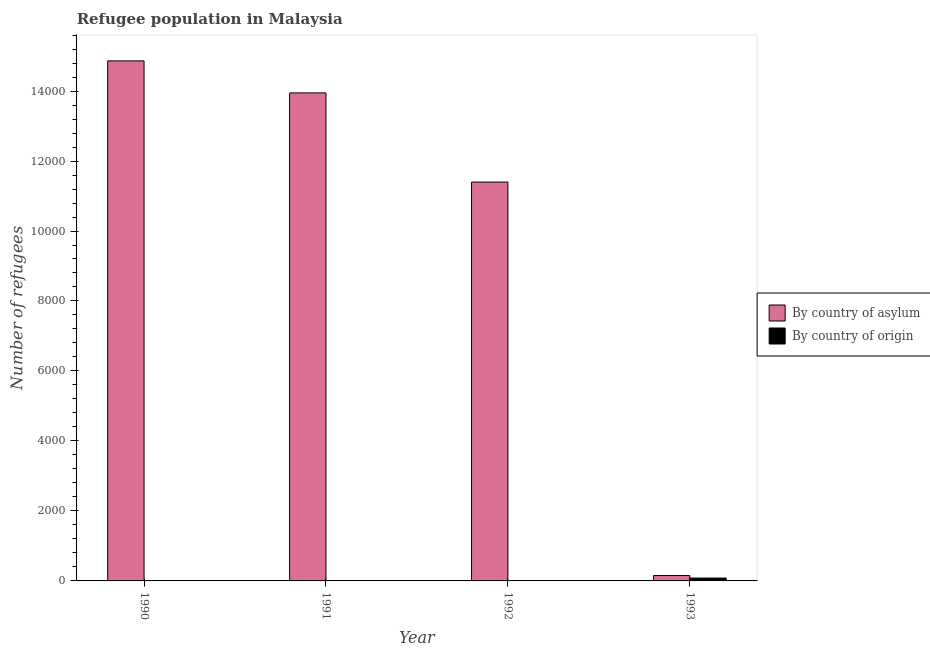How many groups of bars are there?
Offer a terse response. 4. Are the number of bars per tick equal to the number of legend labels?
Make the answer very short. Yes. How many bars are there on the 4th tick from the right?
Your answer should be compact. 2. What is the label of the 1st group of bars from the left?
Give a very brief answer. 1990. What is the number of refugees by country of origin in 1990?
Your answer should be very brief. 3. Across all years, what is the maximum number of refugees by country of asylum?
Provide a short and direct response. 1.49e+04. Across all years, what is the minimum number of refugees by country of origin?
Offer a terse response. 3. In which year was the number of refugees by country of asylum minimum?
Offer a very short reply. 1993. What is the total number of refugees by country of asylum in the graph?
Your answer should be compact. 4.04e+04. What is the difference between the number of refugees by country of asylum in 1990 and that in 1991?
Keep it short and to the point. 915. What is the difference between the number of refugees by country of asylum in 1991 and the number of refugees by country of origin in 1993?
Your answer should be compact. 1.38e+04. What is the average number of refugees by country of asylum per year?
Your answer should be very brief. 1.01e+04. What is the ratio of the number of refugees by country of asylum in 1991 to that in 1992?
Offer a very short reply. 1.22. Is the number of refugees by country of origin in 1991 less than that in 1992?
Offer a very short reply. No. What is the difference between the highest and the second highest number of refugees by country of asylum?
Your answer should be compact. 915. What is the difference between the highest and the lowest number of refugees by country of origin?
Offer a terse response. 79. In how many years, is the number of refugees by country of origin greater than the average number of refugees by country of origin taken over all years?
Your answer should be compact. 1. Is the sum of the number of refugees by country of asylum in 1991 and 1993 greater than the maximum number of refugees by country of origin across all years?
Give a very brief answer. No. What does the 1st bar from the left in 1990 represents?
Offer a terse response. By country of asylum. What does the 1st bar from the right in 1990 represents?
Offer a very short reply. By country of origin. Are all the bars in the graph horizontal?
Offer a very short reply. No. Does the graph contain grids?
Your answer should be compact. No. How many legend labels are there?
Offer a very short reply. 2. What is the title of the graph?
Keep it short and to the point. Refugee population in Malaysia. What is the label or title of the Y-axis?
Provide a succinct answer. Number of refugees. What is the Number of refugees in By country of asylum in 1990?
Provide a succinct answer. 1.49e+04. What is the Number of refugees of By country of origin in 1990?
Make the answer very short. 3. What is the Number of refugees in By country of asylum in 1991?
Offer a terse response. 1.39e+04. What is the Number of refugees in By country of origin in 1991?
Make the answer very short. 4. What is the Number of refugees in By country of asylum in 1992?
Make the answer very short. 1.14e+04. What is the Number of refugees in By country of asylum in 1993?
Your answer should be very brief. 154. What is the Number of refugees of By country of origin in 1993?
Provide a succinct answer. 82. Across all years, what is the maximum Number of refugees in By country of asylum?
Provide a succinct answer. 1.49e+04. Across all years, what is the minimum Number of refugees of By country of asylum?
Provide a short and direct response. 154. What is the total Number of refugees in By country of asylum in the graph?
Your answer should be very brief. 4.04e+04. What is the total Number of refugees in By country of origin in the graph?
Make the answer very short. 93. What is the difference between the Number of refugees in By country of asylum in 1990 and that in 1991?
Offer a terse response. 915. What is the difference between the Number of refugees of By country of origin in 1990 and that in 1991?
Keep it short and to the point. -1. What is the difference between the Number of refugees in By country of asylum in 1990 and that in 1992?
Offer a terse response. 3463. What is the difference between the Number of refugees of By country of asylum in 1990 and that in 1993?
Your response must be concise. 1.47e+04. What is the difference between the Number of refugees in By country of origin in 1990 and that in 1993?
Provide a short and direct response. -79. What is the difference between the Number of refugees in By country of asylum in 1991 and that in 1992?
Your response must be concise. 2548. What is the difference between the Number of refugees of By country of origin in 1991 and that in 1992?
Your answer should be compact. 0. What is the difference between the Number of refugees of By country of asylum in 1991 and that in 1993?
Make the answer very short. 1.38e+04. What is the difference between the Number of refugees in By country of origin in 1991 and that in 1993?
Your answer should be very brief. -78. What is the difference between the Number of refugees of By country of asylum in 1992 and that in 1993?
Your answer should be compact. 1.12e+04. What is the difference between the Number of refugees of By country of origin in 1992 and that in 1993?
Offer a very short reply. -78. What is the difference between the Number of refugees of By country of asylum in 1990 and the Number of refugees of By country of origin in 1991?
Give a very brief answer. 1.49e+04. What is the difference between the Number of refugees in By country of asylum in 1990 and the Number of refugees in By country of origin in 1992?
Your response must be concise. 1.49e+04. What is the difference between the Number of refugees in By country of asylum in 1990 and the Number of refugees in By country of origin in 1993?
Your response must be concise. 1.48e+04. What is the difference between the Number of refugees of By country of asylum in 1991 and the Number of refugees of By country of origin in 1992?
Offer a terse response. 1.39e+04. What is the difference between the Number of refugees in By country of asylum in 1991 and the Number of refugees in By country of origin in 1993?
Keep it short and to the point. 1.39e+04. What is the difference between the Number of refugees of By country of asylum in 1992 and the Number of refugees of By country of origin in 1993?
Provide a succinct answer. 1.13e+04. What is the average Number of refugees of By country of asylum per year?
Give a very brief answer. 1.01e+04. What is the average Number of refugees in By country of origin per year?
Your response must be concise. 23.25. In the year 1990, what is the difference between the Number of refugees of By country of asylum and Number of refugees of By country of origin?
Your answer should be very brief. 1.49e+04. In the year 1991, what is the difference between the Number of refugees in By country of asylum and Number of refugees in By country of origin?
Offer a terse response. 1.39e+04. In the year 1992, what is the difference between the Number of refugees of By country of asylum and Number of refugees of By country of origin?
Your response must be concise. 1.14e+04. In the year 1993, what is the difference between the Number of refugees in By country of asylum and Number of refugees in By country of origin?
Your answer should be very brief. 72. What is the ratio of the Number of refugees of By country of asylum in 1990 to that in 1991?
Your answer should be compact. 1.07. What is the ratio of the Number of refugees of By country of origin in 1990 to that in 1991?
Your response must be concise. 0.75. What is the ratio of the Number of refugees of By country of asylum in 1990 to that in 1992?
Provide a short and direct response. 1.3. What is the ratio of the Number of refugees of By country of asylum in 1990 to that in 1993?
Offer a very short reply. 96.51. What is the ratio of the Number of refugees of By country of origin in 1990 to that in 1993?
Give a very brief answer. 0.04. What is the ratio of the Number of refugees in By country of asylum in 1991 to that in 1992?
Ensure brevity in your answer.  1.22. What is the ratio of the Number of refugees in By country of origin in 1991 to that in 1992?
Your answer should be very brief. 1. What is the ratio of the Number of refugees of By country of asylum in 1991 to that in 1993?
Give a very brief answer. 90.56. What is the ratio of the Number of refugees in By country of origin in 1991 to that in 1993?
Your response must be concise. 0.05. What is the ratio of the Number of refugees of By country of asylum in 1992 to that in 1993?
Give a very brief answer. 74.02. What is the ratio of the Number of refugees in By country of origin in 1992 to that in 1993?
Keep it short and to the point. 0.05. What is the difference between the highest and the second highest Number of refugees in By country of asylum?
Your response must be concise. 915. What is the difference between the highest and the lowest Number of refugees in By country of asylum?
Your answer should be compact. 1.47e+04. What is the difference between the highest and the lowest Number of refugees in By country of origin?
Ensure brevity in your answer.  79. 